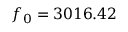Convert formula to latex. <formula><loc_0><loc_0><loc_500><loc_500>f _ { 0 } = 3 0 1 6 . 4 2</formula> 